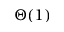<formula> <loc_0><loc_0><loc_500><loc_500>\Theta ( 1 )</formula> 